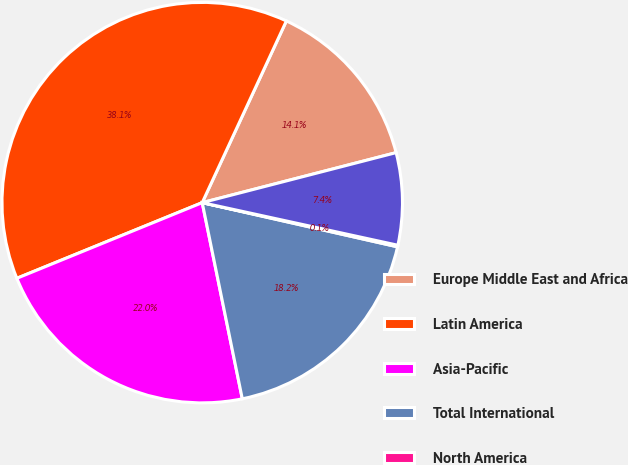<chart> <loc_0><loc_0><loc_500><loc_500><pie_chart><fcel>Europe Middle East and Africa<fcel>Latin America<fcel>Asia-Pacific<fcel>Total International<fcel>North America<fcel>Total sales<nl><fcel>14.08%<fcel>38.07%<fcel>22.04%<fcel>18.25%<fcel>0.13%<fcel>7.43%<nl></chart> 